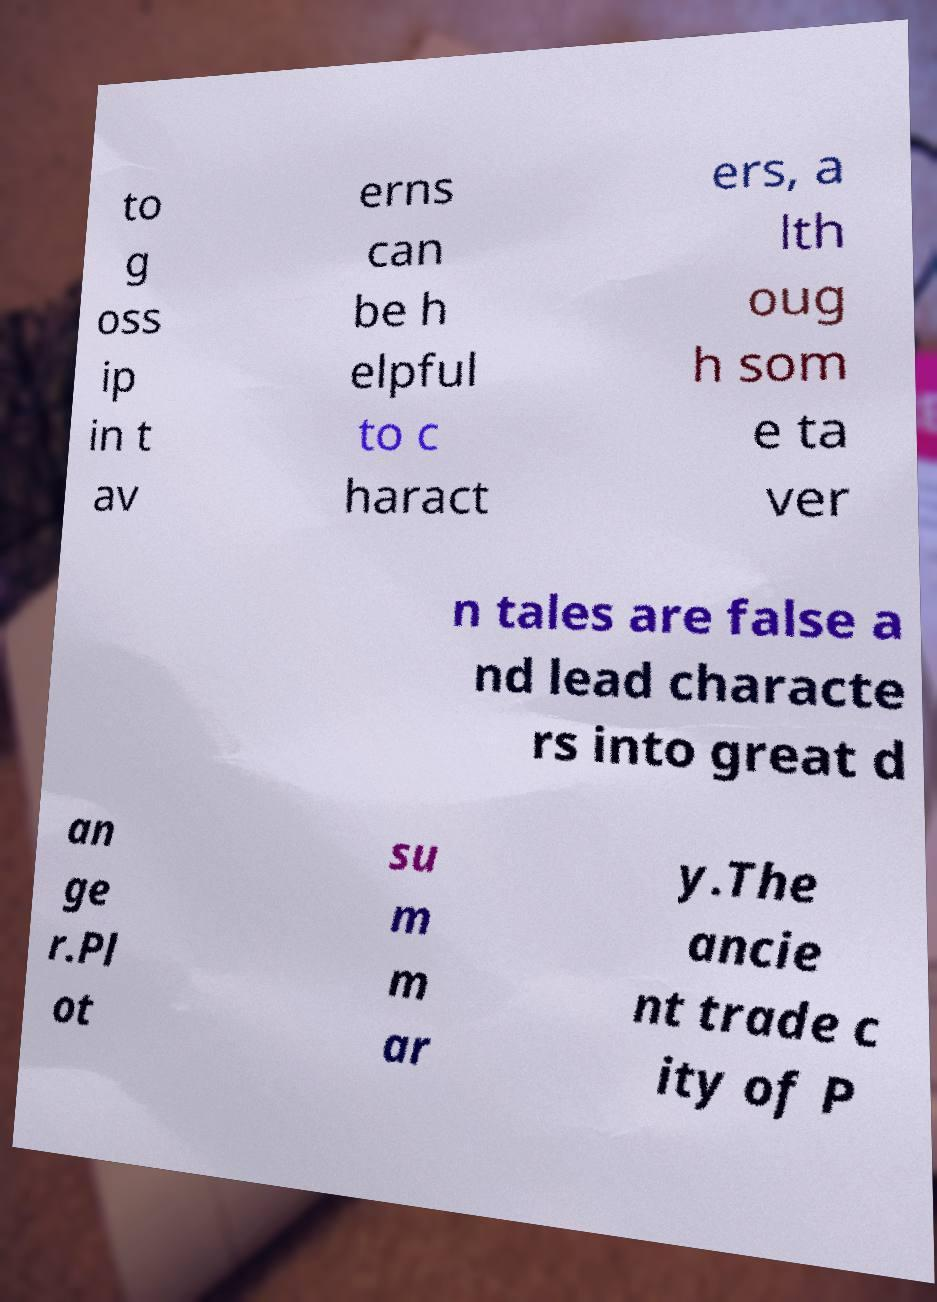Could you extract and type out the text from this image? to g oss ip in t av erns can be h elpful to c haract ers, a lth oug h som e ta ver n tales are false a nd lead characte rs into great d an ge r.Pl ot su m m ar y.The ancie nt trade c ity of P 